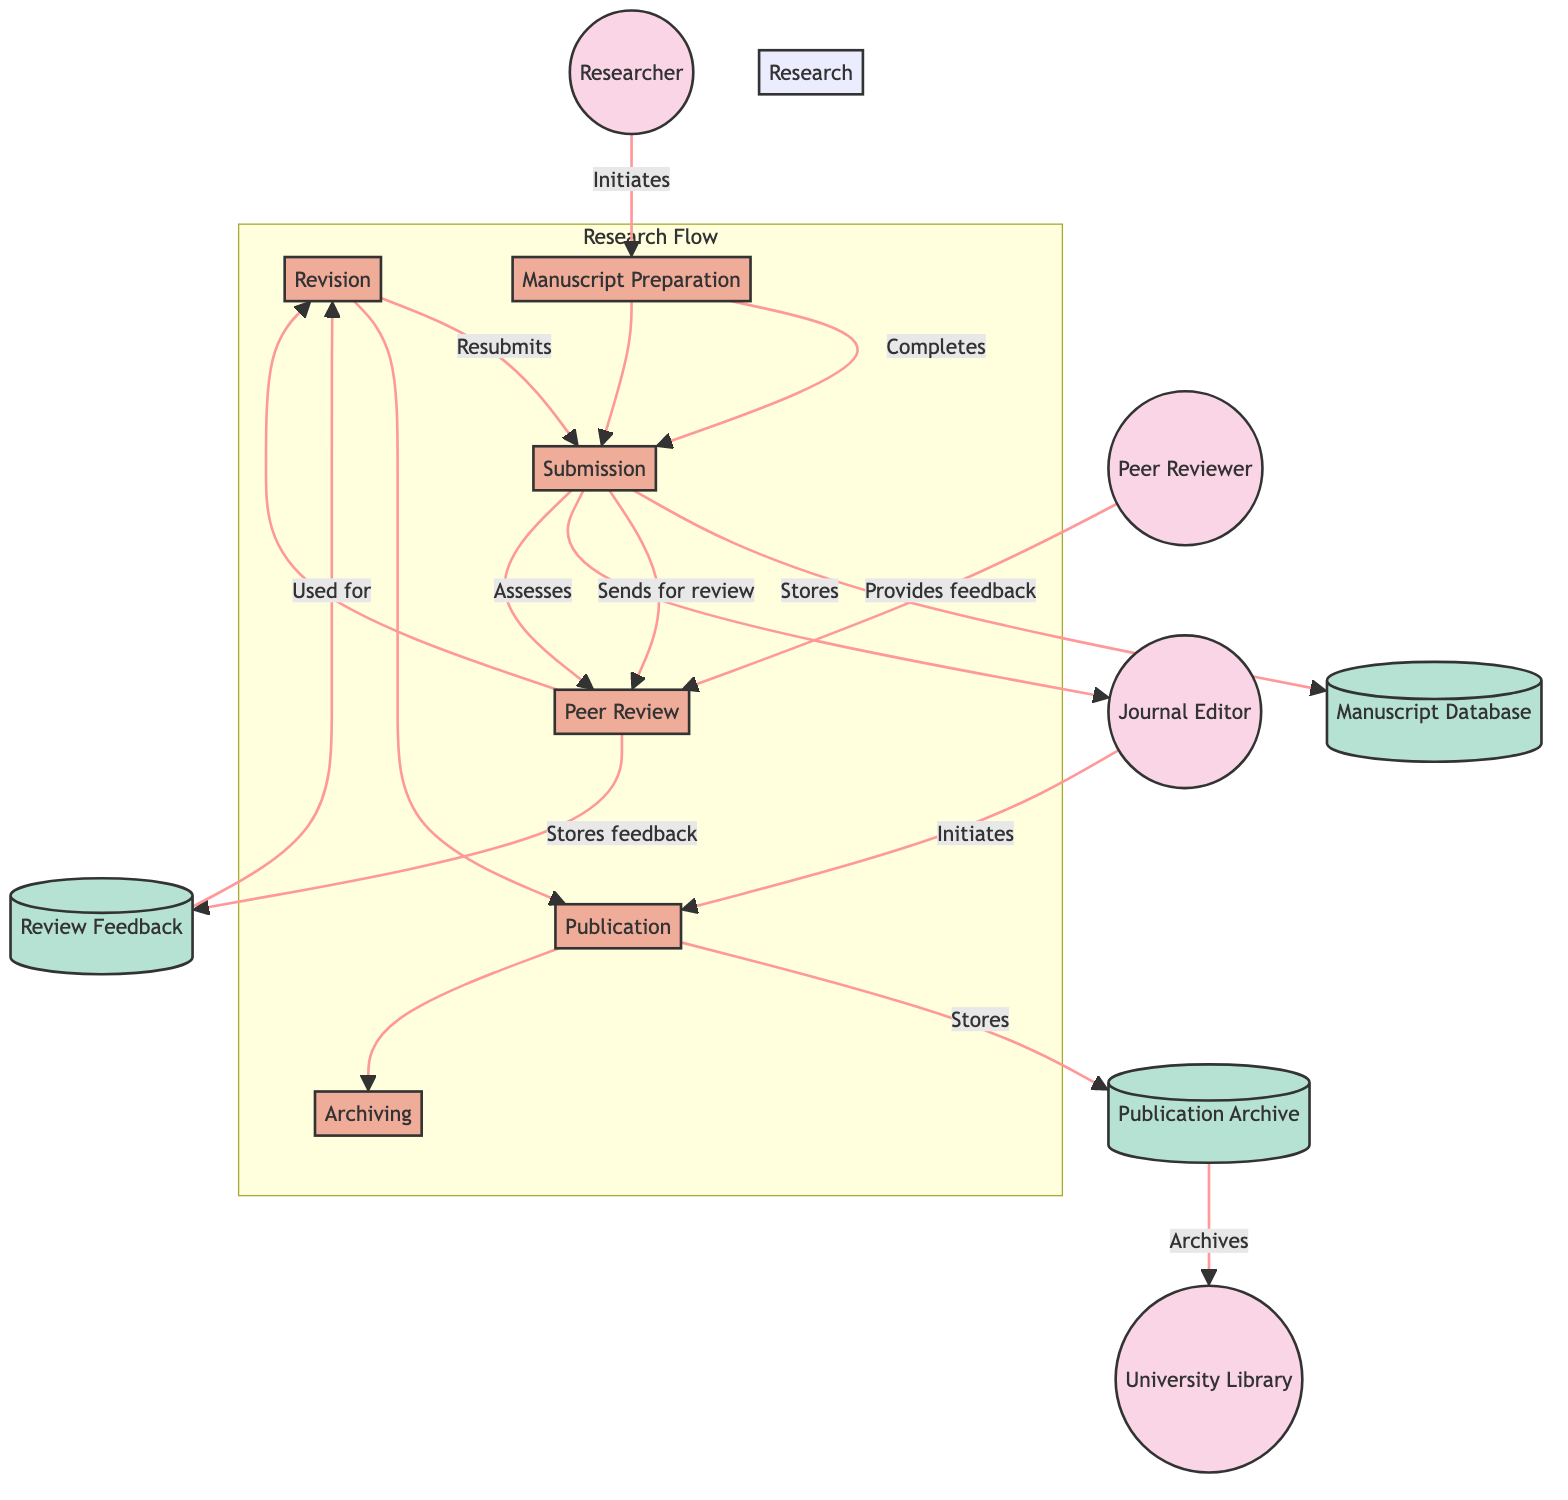What is the first process in the workflow? The diagram indicates that the workflow begins with the "Manuscript Preparation" process, which is the first process after the researcher initiates the workflow.
Answer: Manuscript Preparation How many external entities are present in the diagram? By counting the external entities listed in the diagram, we find there are four entities: Researcher, Peer Reviewer, Journal Editor, and University Library.
Answer: Four Which entity provides feedback to the peer review process? The diagram clearly shows that the "Peer Reviewer" provides feedback to the peer review process as indicated by the data flow between them.
Answer: Peer Reviewer What database stores the review feedback? According to the diagram, the "Review Feedback" database is specifically used to store the feedback provided by the peer reviewers during the review process.
Answer: Review Feedback What process follows the peer review phase? The diagram illustrates that the process which follows "Peer Review" is "Revision," where the feedback is used to make necessary changes to the manuscript.
Answer: Revision How many processes are involved in the publication workflow? Counting the processes depicted in the diagram, there are six distinct processes: Manuscript Preparation, Submission, Peer Review, Revision, Publication, and Archiving.
Answer: Six After publication, where is the final paper archived? The diagram indicates that after the publication process, the final paper is archived in the "University Library," which serves as the digital repository for the published works.
Answer: University Library What action occurs between the submission and peer review processes? The data flow between "Submission" and "Peer Review" indicates that the action occurring is "Sending for review," which specifies what is happening in that transition.
Answer: Sends for review Who initiates the publication process? The diagram shows that the "Journal Editor" initiates the publication process after assessing the resubmitted manuscript, highlighting their role in this workflow.
Answer: Journal Editor 